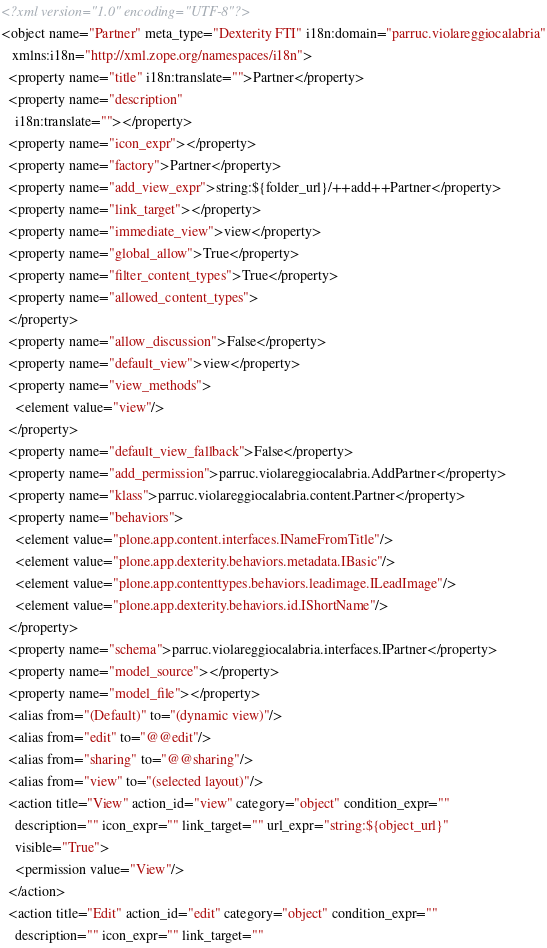Convert code to text. <code><loc_0><loc_0><loc_500><loc_500><_XML_><?xml version="1.0" encoding="UTF-8"?>
<object name="Partner" meta_type="Dexterity FTI" i18n:domain="parruc.violareggiocalabria"
   xmlns:i18n="http://xml.zope.org/namespaces/i18n">
  <property name="title" i18n:translate="">Partner</property>
  <property name="description"
    i18n:translate=""></property>
  <property name="icon_expr"></property>
  <property name="factory">Partner</property>
  <property name="add_view_expr">string:${folder_url}/++add++Partner</property>
  <property name="link_target"></property>
  <property name="immediate_view">view</property>
  <property name="global_allow">True</property>
  <property name="filter_content_types">True</property>
  <property name="allowed_content_types">
  </property>
  <property name="allow_discussion">False</property>
  <property name="default_view">view</property>
  <property name="view_methods">
    <element value="view"/>
  </property>
  <property name="default_view_fallback">False</property>
  <property name="add_permission">parruc.violareggiocalabria.AddPartner</property>
  <property name="klass">parruc.violareggiocalabria.content.Partner</property>
  <property name="behaviors">
    <element value="plone.app.content.interfaces.INameFromTitle"/>
    <element value="plone.app.dexterity.behaviors.metadata.IBasic"/>
    <element value="plone.app.contenttypes.behaviors.leadimage.ILeadImage"/>
    <element value="plone.app.dexterity.behaviors.id.IShortName"/>
  </property>
  <property name="schema">parruc.violareggiocalabria.interfaces.IPartner</property>
  <property name="model_source"></property>
  <property name="model_file"></property>
  <alias from="(Default)" to="(dynamic view)"/>
  <alias from="edit" to="@@edit"/>
  <alias from="sharing" to="@@sharing"/>
  <alias from="view" to="(selected layout)"/>
  <action title="View" action_id="view" category="object" condition_expr=""
    description="" icon_expr="" link_target="" url_expr="string:${object_url}"
    visible="True">
    <permission value="View"/>
  </action>
  <action title="Edit" action_id="edit" category="object" condition_expr=""
    description="" icon_expr="" link_target=""</code> 